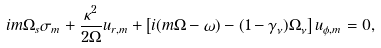<formula> <loc_0><loc_0><loc_500><loc_500>i m \Omega _ { s } \sigma _ { m } + \frac { \kappa ^ { 2 } } { 2 \Omega } u _ { r , m } + \left [ i ( m \Omega - \omega ) - ( 1 - \gamma _ { \nu } ) \Omega _ { \nu } \right ] u _ { \phi , m } = 0 ,</formula> 